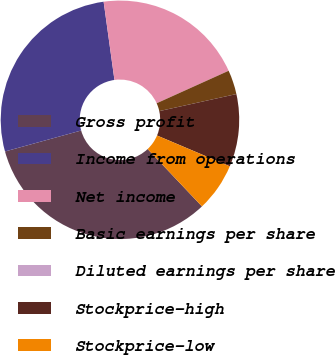Convert chart. <chart><loc_0><loc_0><loc_500><loc_500><pie_chart><fcel>Gross profit<fcel>Income from operations<fcel>Net income<fcel>Basic earnings per share<fcel>Diluted earnings per share<fcel>Stockprice-high<fcel>Stockprice-low<nl><fcel>32.79%<fcel>27.09%<fcel>20.44%<fcel>3.28%<fcel>0.0%<fcel>9.84%<fcel>6.56%<nl></chart> 